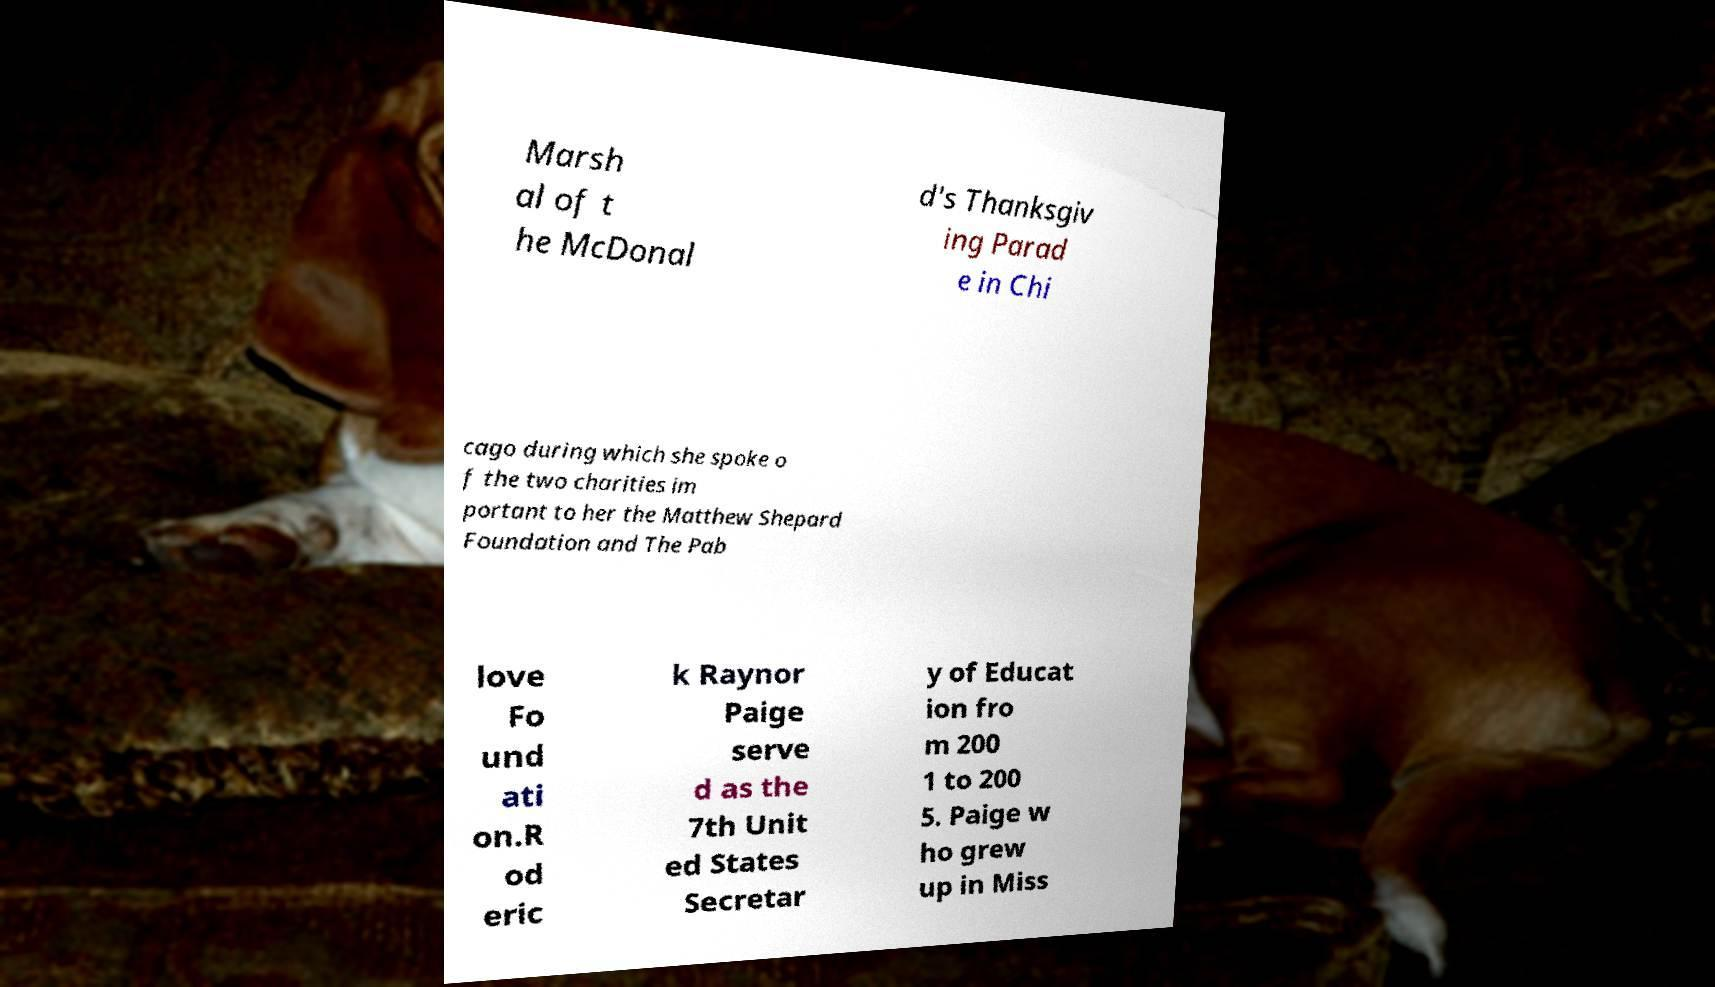Can you accurately transcribe the text from the provided image for me? Marsh al of t he McDonal d's Thanksgiv ing Parad e in Chi cago during which she spoke o f the two charities im portant to her the Matthew Shepard Foundation and The Pab love Fo und ati on.R od eric k Raynor Paige serve d as the 7th Unit ed States Secretar y of Educat ion fro m 200 1 to 200 5. Paige w ho grew up in Miss 